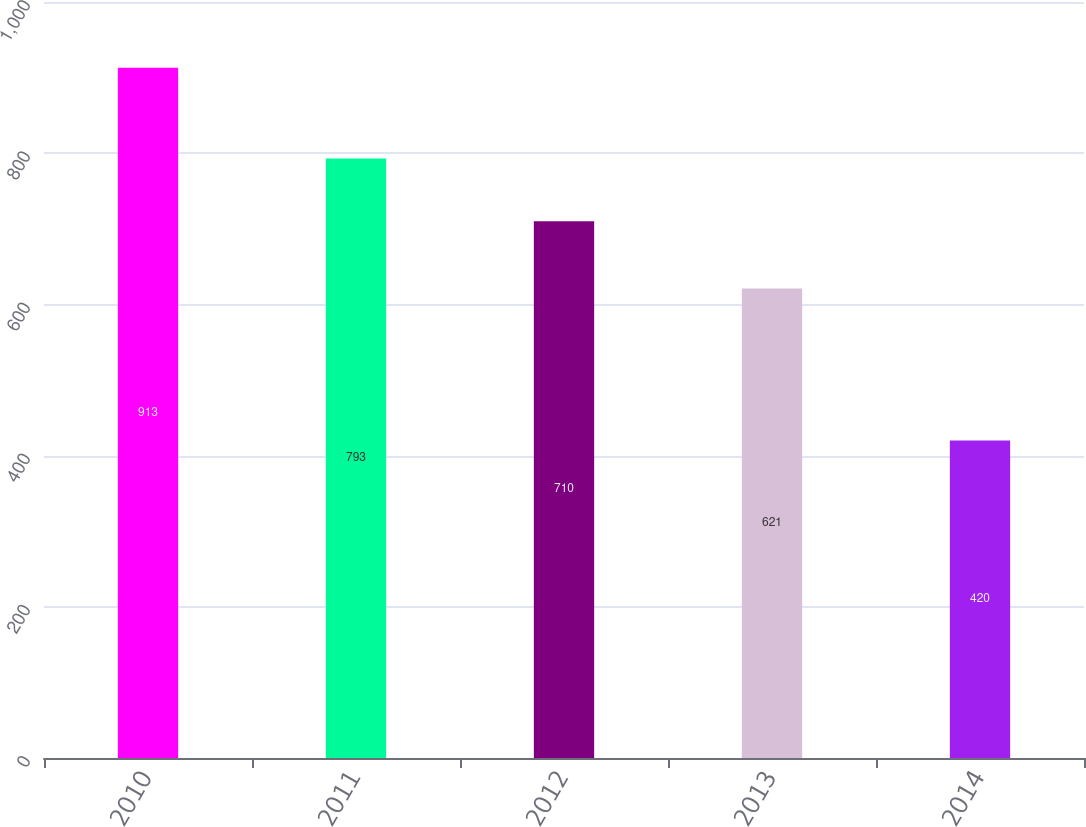Convert chart to OTSL. <chart><loc_0><loc_0><loc_500><loc_500><bar_chart><fcel>2010<fcel>2011<fcel>2012<fcel>2013<fcel>2014<nl><fcel>913<fcel>793<fcel>710<fcel>621<fcel>420<nl></chart> 